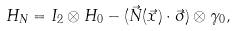<formula> <loc_0><loc_0><loc_500><loc_500>H _ { N } = I _ { 2 } \otimes H _ { 0 } - ( \vec { N } ( \vec { x } ) \cdot \vec { \sigma } ) \otimes \gamma _ { 0 } ,</formula> 